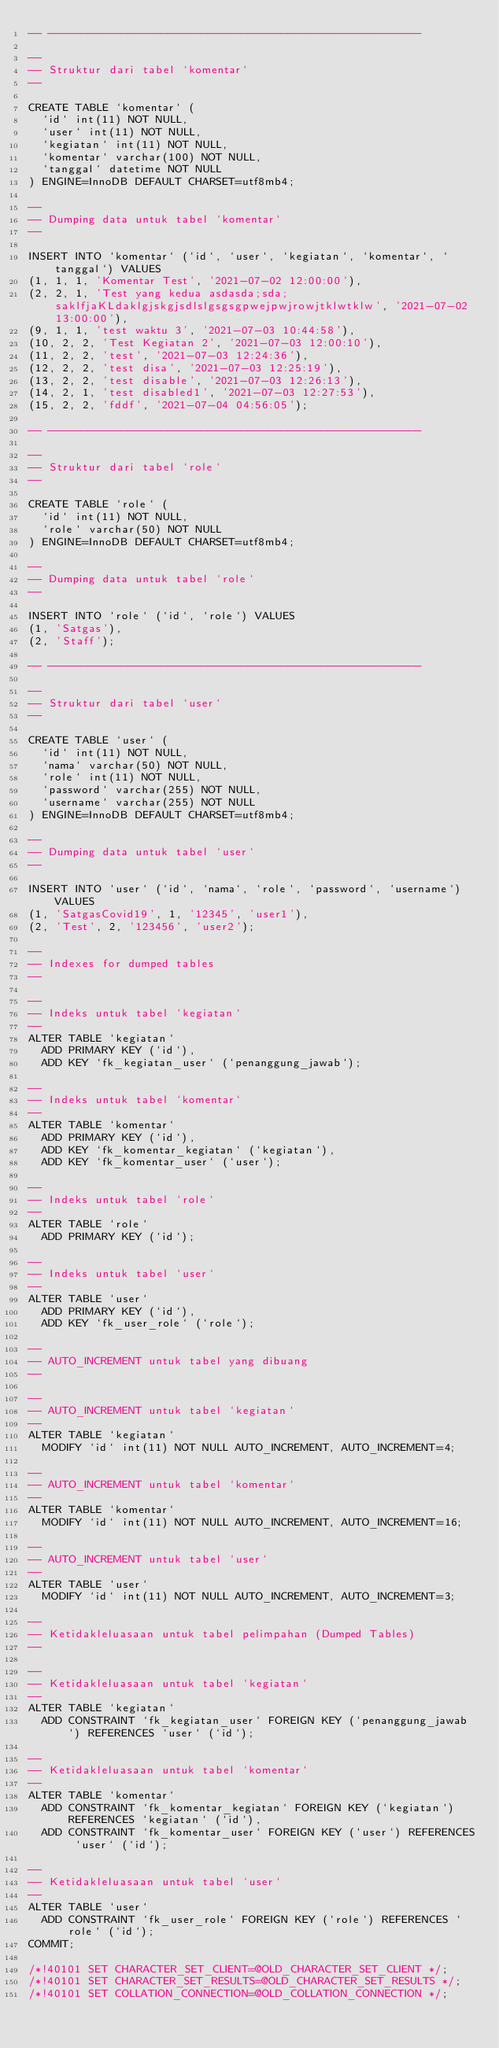<code> <loc_0><loc_0><loc_500><loc_500><_SQL_>-- --------------------------------------------------------

--
-- Struktur dari tabel `komentar`
--

CREATE TABLE `komentar` (
  `id` int(11) NOT NULL,
  `user` int(11) NOT NULL,
  `kegiatan` int(11) NOT NULL,
  `komentar` varchar(100) NOT NULL,
  `tanggal` datetime NOT NULL
) ENGINE=InnoDB DEFAULT CHARSET=utf8mb4;

--
-- Dumping data untuk tabel `komentar`
--

INSERT INTO `komentar` (`id`, `user`, `kegiatan`, `komentar`, `tanggal`) VALUES
(1, 1, 1, 'Komentar Test', '2021-07-02 12:00:00'),
(2, 2, 1, 'Test yang kedua asdasda;sda;saklfjaKLdaklgjskgjsdlslgsgsgpwejpwjrowjtklwtklw', '2021-07-02 13:00:00'),
(9, 1, 1, 'test waktu 3', '2021-07-03 10:44:58'),
(10, 2, 2, 'Test Kegiatan 2', '2021-07-03 12:00:10'),
(11, 2, 2, 'test', '2021-07-03 12:24:36'),
(12, 2, 2, 'test disa', '2021-07-03 12:25:19'),
(13, 2, 2, 'test disable', '2021-07-03 12:26:13'),
(14, 2, 1, 'test disabled1', '2021-07-03 12:27:53'),
(15, 2, 2, 'fddf', '2021-07-04 04:56:05');

-- --------------------------------------------------------

--
-- Struktur dari tabel `role`
--

CREATE TABLE `role` (
  `id` int(11) NOT NULL,
  `role` varchar(50) NOT NULL
) ENGINE=InnoDB DEFAULT CHARSET=utf8mb4;

--
-- Dumping data untuk tabel `role`
--

INSERT INTO `role` (`id`, `role`) VALUES
(1, 'Satgas'),
(2, 'Staff');

-- --------------------------------------------------------

--
-- Struktur dari tabel `user`
--

CREATE TABLE `user` (
  `id` int(11) NOT NULL,
  `nama` varchar(50) NOT NULL,
  `role` int(11) NOT NULL,
  `password` varchar(255) NOT NULL,
  `username` varchar(255) NOT NULL
) ENGINE=InnoDB DEFAULT CHARSET=utf8mb4;

--
-- Dumping data untuk tabel `user`
--

INSERT INTO `user` (`id`, `nama`, `role`, `password`, `username`) VALUES
(1, 'SatgasCovid19', 1, '12345', 'user1'),
(2, 'Test', 2, '123456', 'user2');

--
-- Indexes for dumped tables
--

--
-- Indeks untuk tabel `kegiatan`
--
ALTER TABLE `kegiatan`
  ADD PRIMARY KEY (`id`),
  ADD KEY `fk_kegiatan_user` (`penanggung_jawab`);

--
-- Indeks untuk tabel `komentar`
--
ALTER TABLE `komentar`
  ADD PRIMARY KEY (`id`),
  ADD KEY `fk_komentar_kegiatan` (`kegiatan`),
  ADD KEY `fk_komentar_user` (`user`);

--
-- Indeks untuk tabel `role`
--
ALTER TABLE `role`
  ADD PRIMARY KEY (`id`);

--
-- Indeks untuk tabel `user`
--
ALTER TABLE `user`
  ADD PRIMARY KEY (`id`),
  ADD KEY `fk_user_role` (`role`);

--
-- AUTO_INCREMENT untuk tabel yang dibuang
--

--
-- AUTO_INCREMENT untuk tabel `kegiatan`
--
ALTER TABLE `kegiatan`
  MODIFY `id` int(11) NOT NULL AUTO_INCREMENT, AUTO_INCREMENT=4;

--
-- AUTO_INCREMENT untuk tabel `komentar`
--
ALTER TABLE `komentar`
  MODIFY `id` int(11) NOT NULL AUTO_INCREMENT, AUTO_INCREMENT=16;

--
-- AUTO_INCREMENT untuk tabel `user`
--
ALTER TABLE `user`
  MODIFY `id` int(11) NOT NULL AUTO_INCREMENT, AUTO_INCREMENT=3;

--
-- Ketidakleluasaan untuk tabel pelimpahan (Dumped Tables)
--

--
-- Ketidakleluasaan untuk tabel `kegiatan`
--
ALTER TABLE `kegiatan`
  ADD CONSTRAINT `fk_kegiatan_user` FOREIGN KEY (`penanggung_jawab`) REFERENCES `user` (`id`);

--
-- Ketidakleluasaan untuk tabel `komentar`
--
ALTER TABLE `komentar`
  ADD CONSTRAINT `fk_komentar_kegiatan` FOREIGN KEY (`kegiatan`) REFERENCES `kegiatan` (`id`),
  ADD CONSTRAINT `fk_komentar_user` FOREIGN KEY (`user`) REFERENCES `user` (`id`);

--
-- Ketidakleluasaan untuk tabel `user`
--
ALTER TABLE `user`
  ADD CONSTRAINT `fk_user_role` FOREIGN KEY (`role`) REFERENCES `role` (`id`);
COMMIT;

/*!40101 SET CHARACTER_SET_CLIENT=@OLD_CHARACTER_SET_CLIENT */;
/*!40101 SET CHARACTER_SET_RESULTS=@OLD_CHARACTER_SET_RESULTS */;
/*!40101 SET COLLATION_CONNECTION=@OLD_COLLATION_CONNECTION */;
</code> 